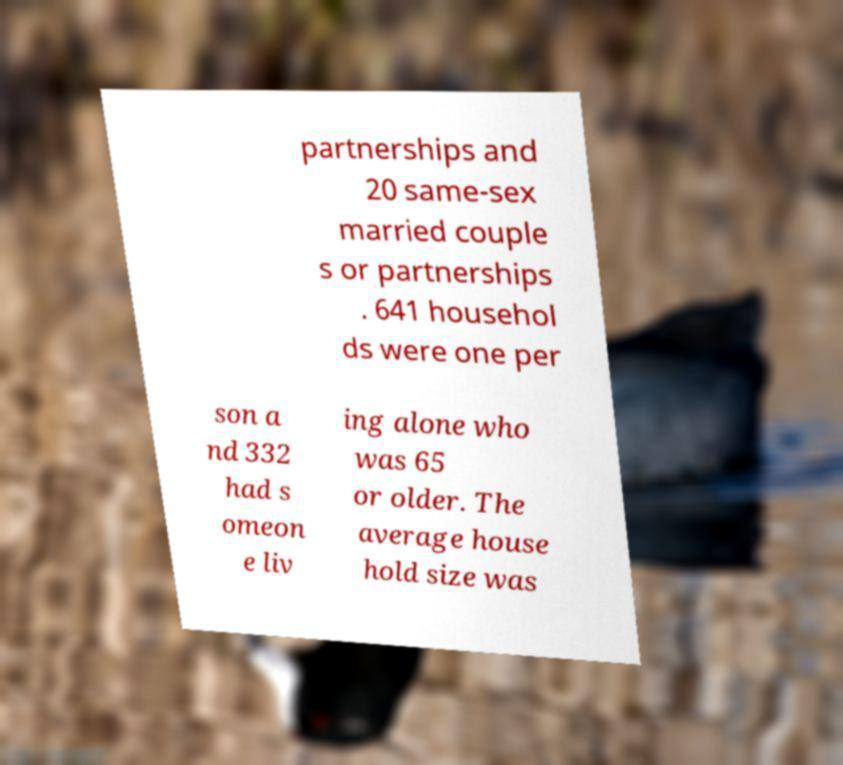What messages or text are displayed in this image? I need them in a readable, typed format. partnerships and 20 same-sex married couple s or partnerships . 641 househol ds were one per son a nd 332 had s omeon e liv ing alone who was 65 or older. The average house hold size was 